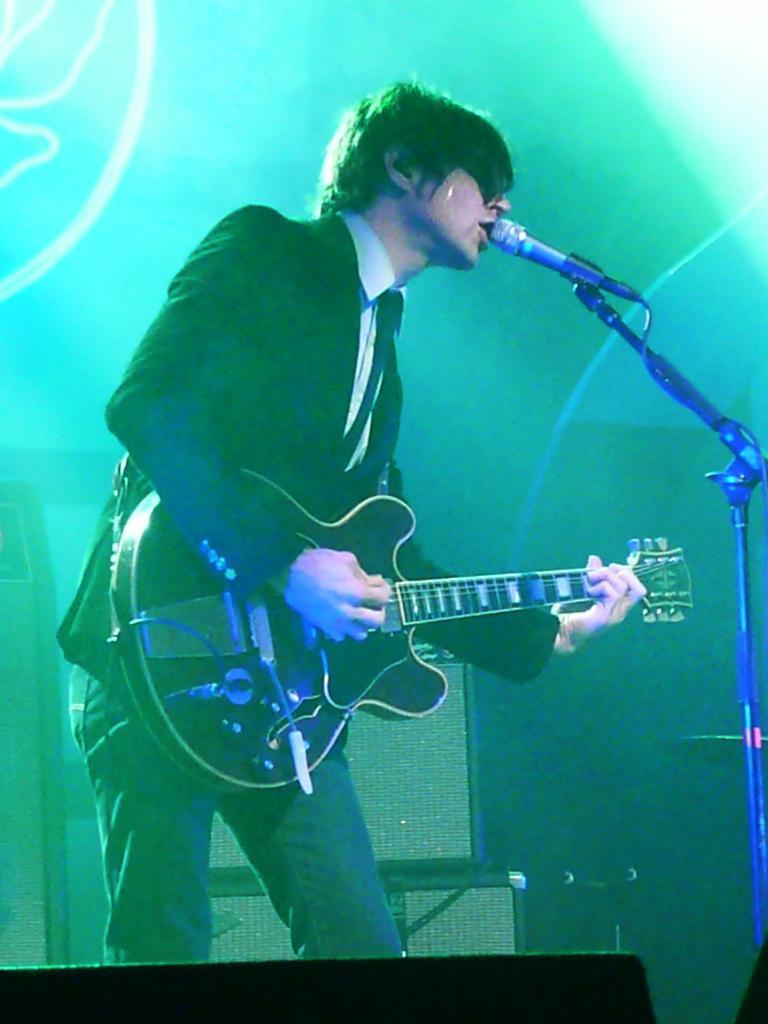How would you summarize this image in a sentence or two? In this image I can see a person standing in-front of the mic and holding the guitar. 